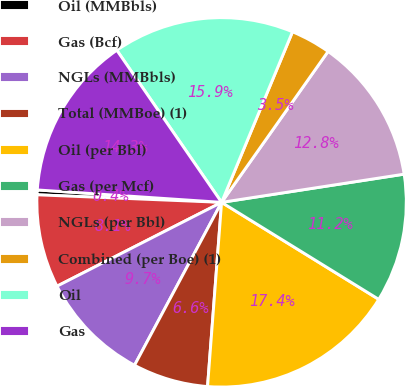Convert chart. <chart><loc_0><loc_0><loc_500><loc_500><pie_chart><fcel>Oil (MMBbls)<fcel>Gas (Bcf)<fcel>NGLs (MMBbls)<fcel>Total (MMBoe) (1)<fcel>Oil (per Bbl)<fcel>Gas (per Mcf)<fcel>NGLs (per Bbl)<fcel>Combined (per Boe) (1)<fcel>Oil<fcel>Gas<nl><fcel>0.42%<fcel>8.15%<fcel>9.69%<fcel>6.6%<fcel>17.41%<fcel>11.24%<fcel>12.78%<fcel>3.51%<fcel>15.87%<fcel>14.33%<nl></chart> 